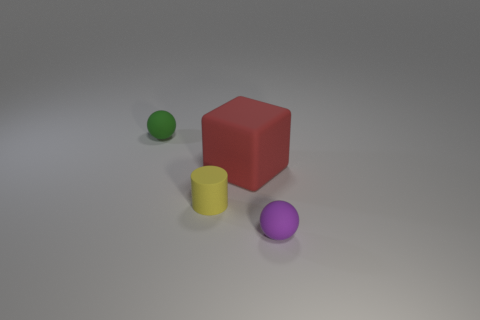Add 4 big cubes. How many objects exist? 8 Add 1 tiny green things. How many tiny green things exist? 2 Subtract 0 blue spheres. How many objects are left? 4 Subtract 1 balls. How many balls are left? 1 Subtract all gray balls. Subtract all gray cylinders. How many balls are left? 2 Subtract all brown cubes. How many green spheres are left? 1 Subtract all blue cylinders. Subtract all tiny cylinders. How many objects are left? 3 Add 4 matte balls. How many matte balls are left? 6 